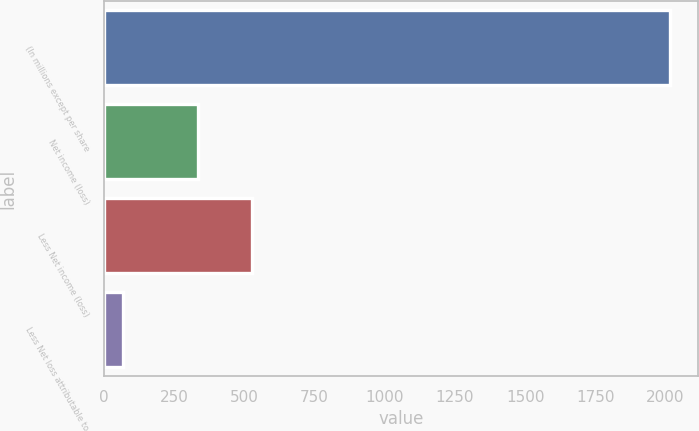Convert chart. <chart><loc_0><loc_0><loc_500><loc_500><bar_chart><fcel>(In millions except per share<fcel>Net income (loss)<fcel>Less Net income (loss)<fcel>Less Net loss attributable to<nl><fcel>2016<fcel>334<fcel>528.7<fcel>69<nl></chart> 